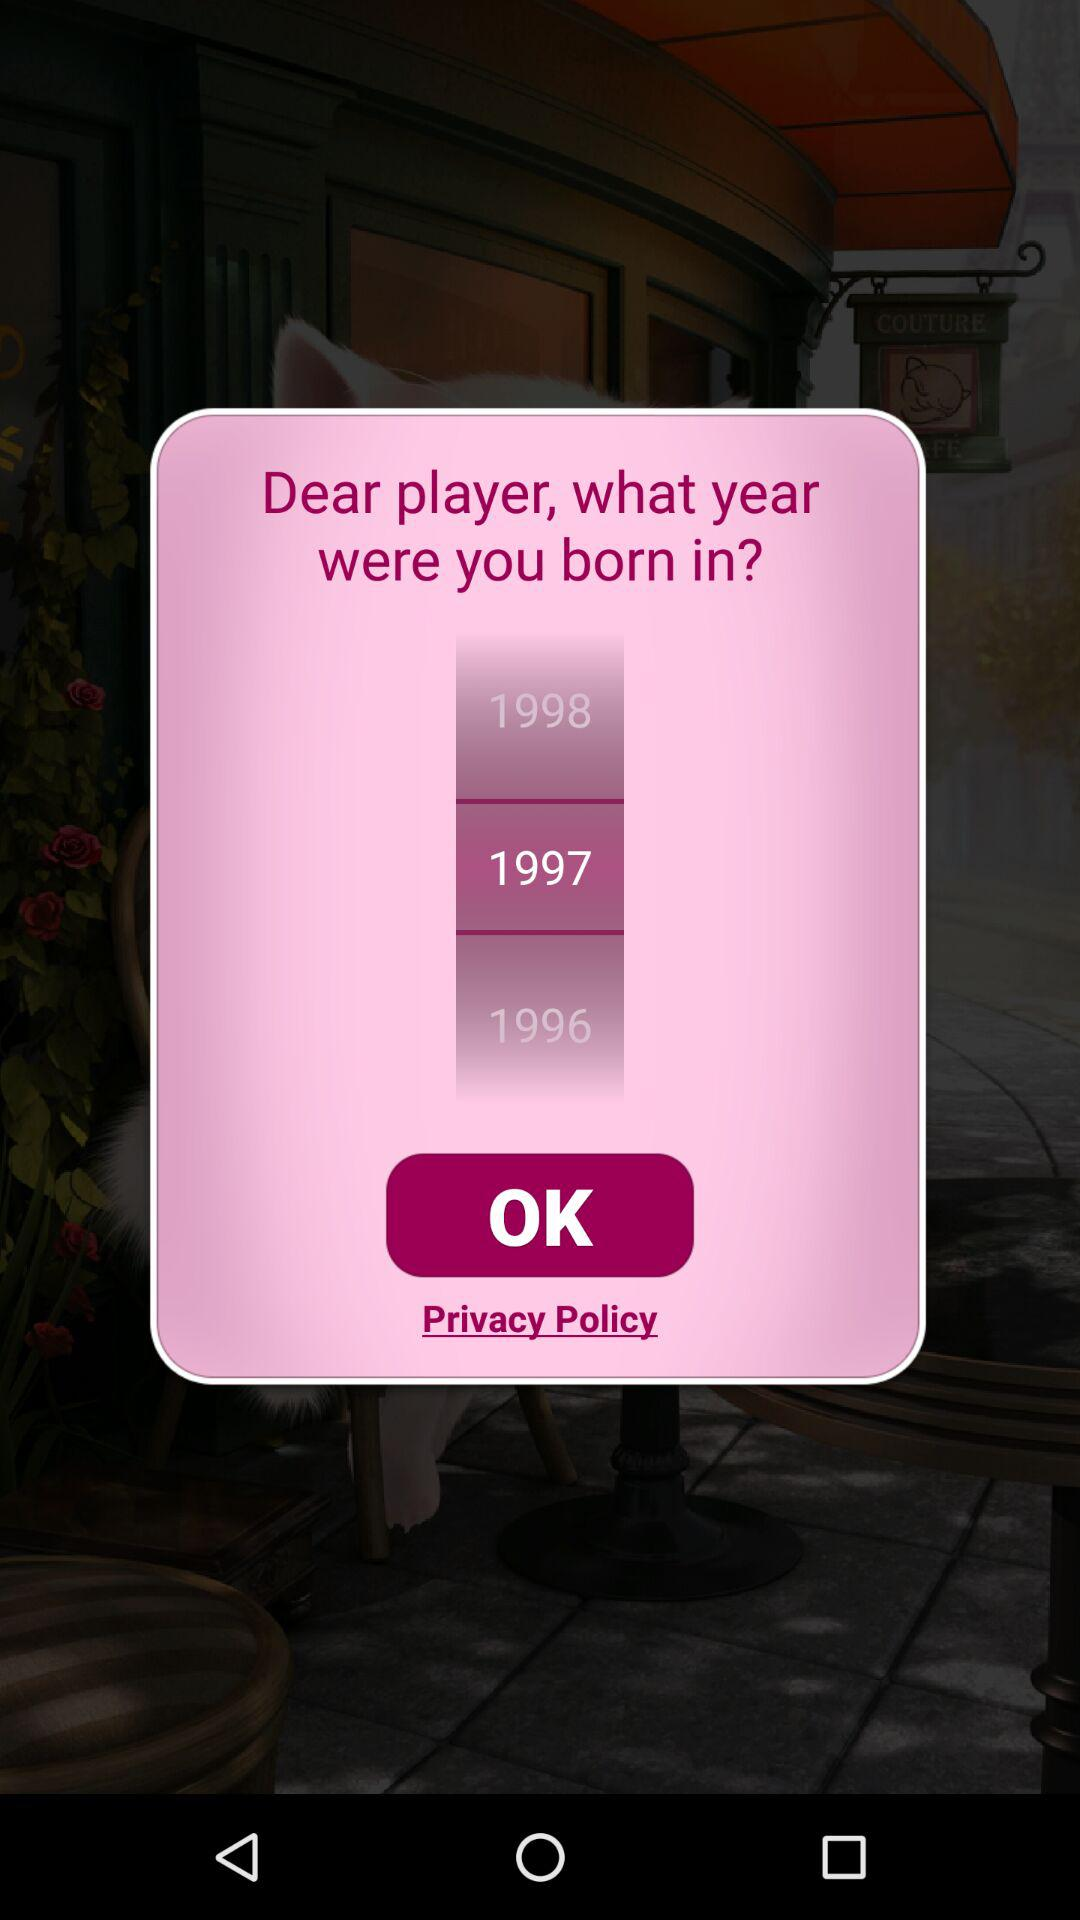What month was the user born in?
When the provided information is insufficient, respond with <no answer>. <no answer> 